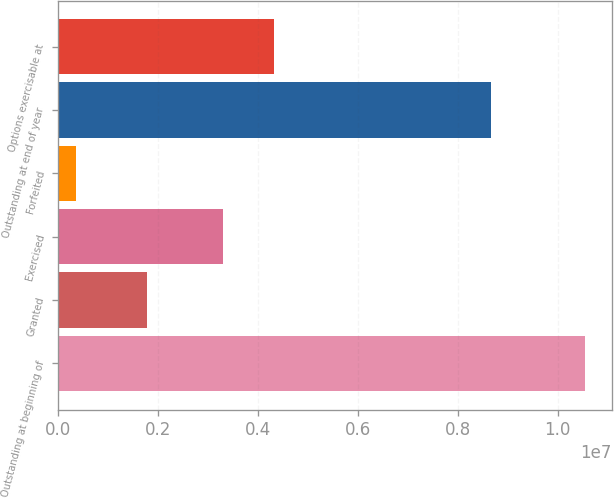Convert chart. <chart><loc_0><loc_0><loc_500><loc_500><bar_chart><fcel>Outstanding at beginning of<fcel>Granted<fcel>Exercised<fcel>Forfeited<fcel>Outstanding at end of year<fcel>Options exercisable at<nl><fcel>1.05539e+07<fcel>1.77911e+06<fcel>3.31599e+06<fcel>356697<fcel>8.66034e+06<fcel>4.33571e+06<nl></chart> 